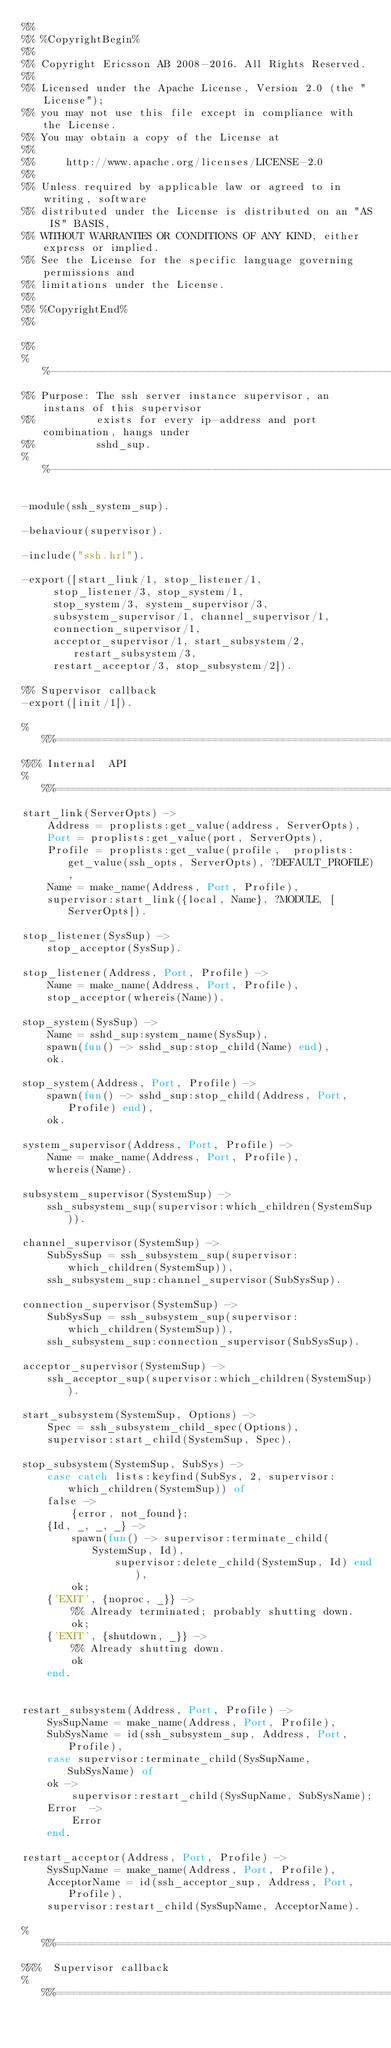Convert code to text. <code><loc_0><loc_0><loc_500><loc_500><_Erlang_>%%
%% %CopyrightBegin%
%%
%% Copyright Ericsson AB 2008-2016. All Rights Reserved.
%%
%% Licensed under the Apache License, Version 2.0 (the "License");
%% you may not use this file except in compliance with the License.
%% You may obtain a copy of the License at
%%
%%     http://www.apache.org/licenses/LICENSE-2.0
%%
%% Unless required by applicable law or agreed to in writing, software
%% distributed under the License is distributed on an "AS IS" BASIS,
%% WITHOUT WARRANTIES OR CONDITIONS OF ANY KIND, either express or implied.
%% See the License for the specific language governing permissions and
%% limitations under the License.
%%
%% %CopyrightEnd%
%%

%%
%%----------------------------------------------------------------------
%% Purpose: The ssh server instance supervisor, an instans of this supervisor
%%          exists for every ip-address and port combination, hangs under  
%%          sshd_sup.
%%----------------------------------------------------------------------

-module(ssh_system_sup).

-behaviour(supervisor).

-include("ssh.hrl").

-export([start_link/1, stop_listener/1,
	 stop_listener/3, stop_system/1,
	 stop_system/3, system_supervisor/3,
	 subsystem_supervisor/1, channel_supervisor/1, 
	 connection_supervisor/1, 
	 acceptor_supervisor/1, start_subsystem/2, restart_subsystem/3,
	 restart_acceptor/3, stop_subsystem/2]).

%% Supervisor callback
-export([init/1]).

%%%=========================================================================
%%% Internal  API
%%%=========================================================================
start_link(ServerOpts) ->
    Address = proplists:get_value(address, ServerOpts),
    Port = proplists:get_value(port, ServerOpts),
    Profile = proplists:get_value(profile,  proplists:get_value(ssh_opts, ServerOpts), ?DEFAULT_PROFILE),
    Name = make_name(Address, Port, Profile),
    supervisor:start_link({local, Name}, ?MODULE, [ServerOpts]).

stop_listener(SysSup) ->
    stop_acceptor(SysSup). 

stop_listener(Address, Port, Profile) ->
    Name = make_name(Address, Port, Profile),
    stop_acceptor(whereis(Name)). 
 
stop_system(SysSup) ->
    Name = sshd_sup:system_name(SysSup),
    spawn(fun() -> sshd_sup:stop_child(Name) end),
    ok.

stop_system(Address, Port, Profile) -> 
    spawn(fun() -> sshd_sup:stop_child(Address, Port, Profile) end),
    ok.

system_supervisor(Address, Port, Profile) ->
    Name = make_name(Address, Port, Profile),
    whereis(Name).

subsystem_supervisor(SystemSup) ->
    ssh_subsystem_sup(supervisor:which_children(SystemSup)).

channel_supervisor(SystemSup) ->
    SubSysSup = ssh_subsystem_sup(supervisor:which_children(SystemSup)),
    ssh_subsystem_sup:channel_supervisor(SubSysSup).

connection_supervisor(SystemSup) ->
    SubSysSup = ssh_subsystem_sup(supervisor:which_children(SystemSup)),
    ssh_subsystem_sup:connection_supervisor(SubSysSup).

acceptor_supervisor(SystemSup) ->
    ssh_acceptor_sup(supervisor:which_children(SystemSup)).

start_subsystem(SystemSup, Options) ->
    Spec = ssh_subsystem_child_spec(Options),
    supervisor:start_child(SystemSup, Spec).

stop_subsystem(SystemSup, SubSys) ->
    case catch lists:keyfind(SubSys, 2, supervisor:which_children(SystemSup)) of
	false ->
	    {error, not_found};
	{Id, _, _, _} ->
	    spawn(fun() -> supervisor:terminate_child(SystemSup, Id),
			   supervisor:delete_child(SystemSup, Id) end),
	    ok;
	{'EXIT', {noproc, _}} ->
	    %% Already terminated; probably shutting down.
	    ok;
	{'EXIT', {shutdown, _}} ->
	    %% Already shutting down.
	    ok
    end.


restart_subsystem(Address, Port, Profile) ->
    SysSupName = make_name(Address, Port, Profile),
    SubSysName = id(ssh_subsystem_sup, Address, Port, Profile),
    case supervisor:terminate_child(SysSupName, SubSysName) of
	ok ->
	    supervisor:restart_child(SysSupName, SubSysName);
	Error  ->
	    Error
    end.

restart_acceptor(Address, Port, Profile) ->
    SysSupName = make_name(Address, Port, Profile),
    AcceptorName = id(ssh_acceptor_sup, Address, Port, Profile),
    supervisor:restart_child(SysSupName, AcceptorName).

%%%=========================================================================
%%%  Supervisor callback
%%%=========================================================================</code> 